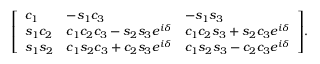<formula> <loc_0><loc_0><loc_500><loc_500>{ \left [ \begin{array} { l l l } { c _ { 1 } } & { - s _ { 1 } c _ { 3 } } & { - s _ { 1 } s _ { 3 } } \\ { s _ { 1 } c _ { 2 } } & { c _ { 1 } c _ { 2 } c _ { 3 } - s _ { 2 } s _ { 3 } e ^ { i \delta } } & { c _ { 1 } c _ { 2 } s _ { 3 } + s _ { 2 } c _ { 3 } e ^ { i \delta } } \\ { s _ { 1 } s _ { 2 } } & { c _ { 1 } s _ { 2 } c _ { 3 } + c _ { 2 } s _ { 3 } e ^ { i \delta } } & { c _ { 1 } s _ { 2 } s _ { 3 } - c _ { 2 } c _ { 3 } e ^ { i \delta } } \end{array} \right ] } .</formula> 